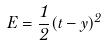Convert formula to latex. <formula><loc_0><loc_0><loc_500><loc_500>E = \frac { 1 } { 2 } ( t - y ) ^ { 2 }</formula> 